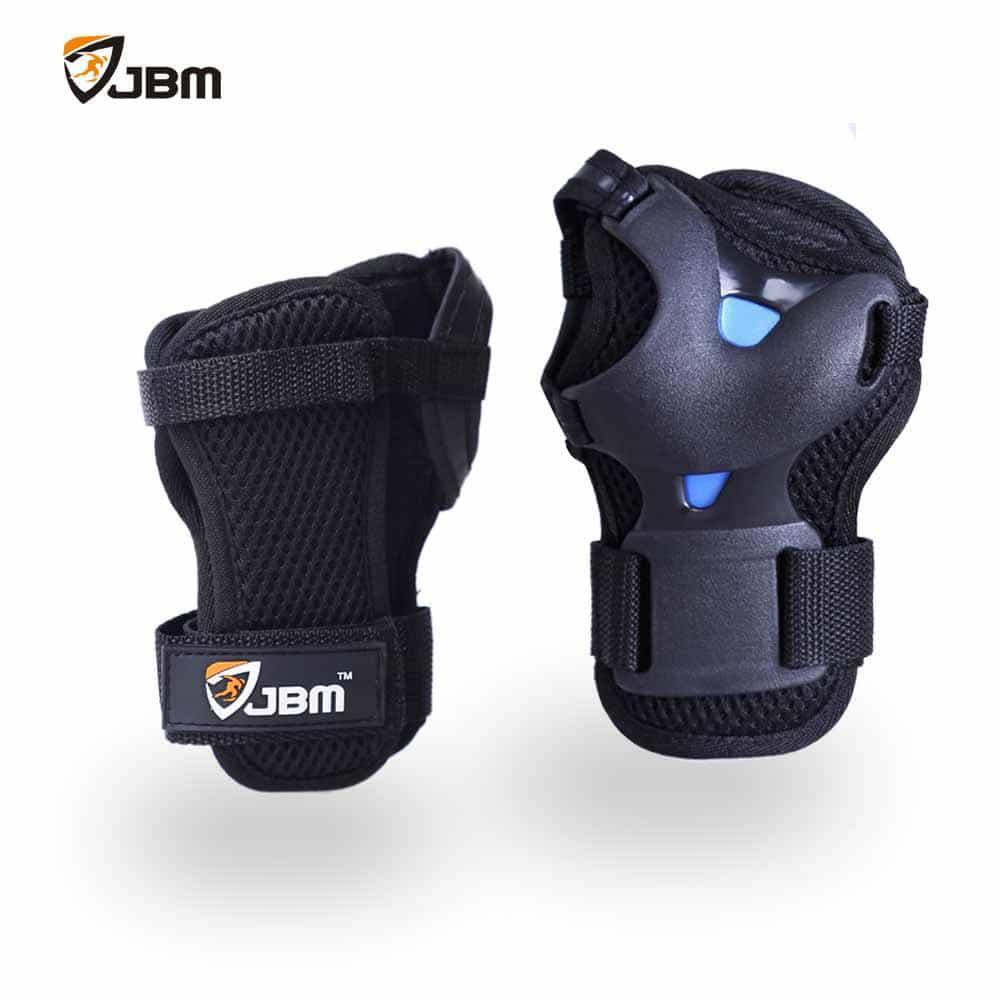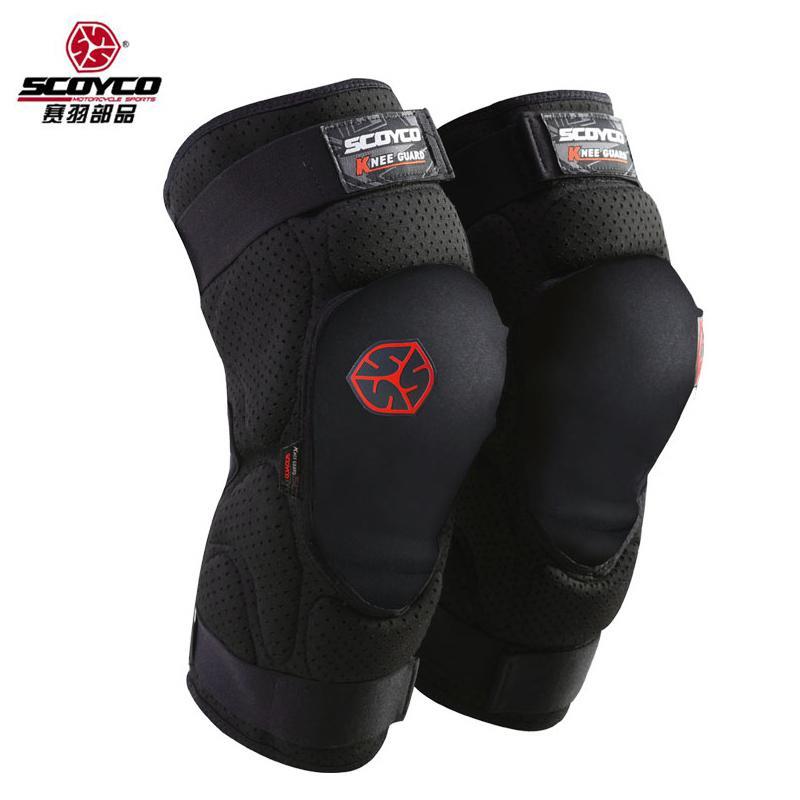The first image is the image on the left, the second image is the image on the right. Given the left and right images, does the statement "An image shows exactly three pads, which are not arranged in one horizontal row." hold true? Answer yes or no. No. The first image is the image on the left, the second image is the image on the right. Assess this claim about the two images: "There is a red marking on at least one of the knee pads in the image on the right side.". Correct or not? Answer yes or no. Yes. 